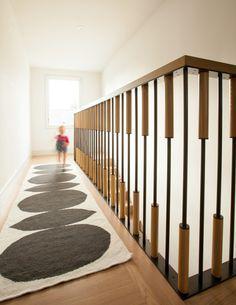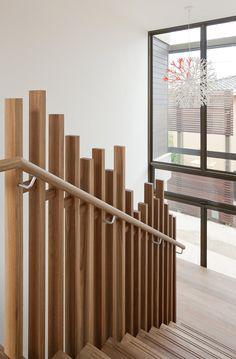The first image is the image on the left, the second image is the image on the right. Analyze the images presented: Is the assertion "The left image shows a staircase that ascends rightward without turning and has an enclosed side and baseboards, a brown wood handrail, and vertical metal bars." valid? Answer yes or no. No. The first image is the image on the left, the second image is the image on the right. For the images displayed, is the sentence "At least one image was taken from upstairs." factually correct? Answer yes or no. Yes. 